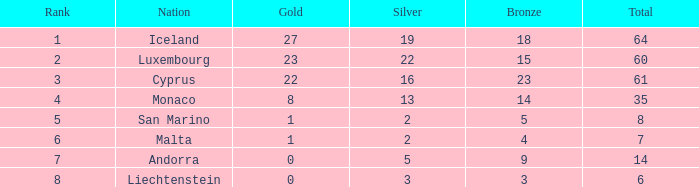How many bronzes does iceland have with in excess of 2 silvers? 18.0. 